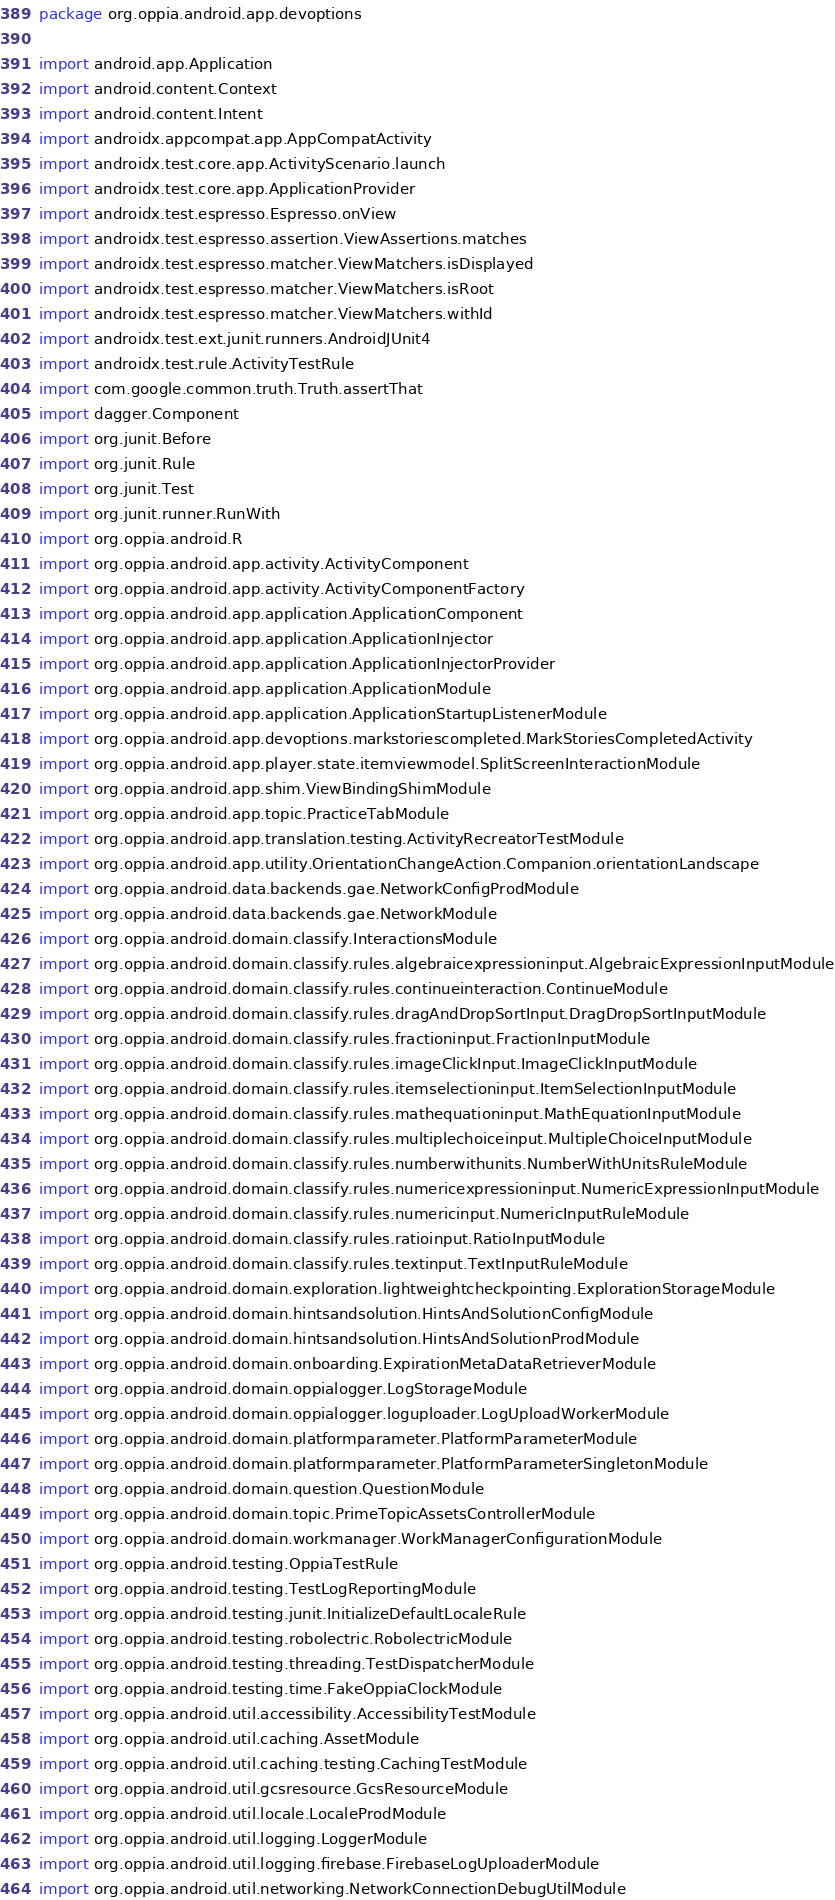<code> <loc_0><loc_0><loc_500><loc_500><_Kotlin_>package org.oppia.android.app.devoptions

import android.app.Application
import android.content.Context
import android.content.Intent
import androidx.appcompat.app.AppCompatActivity
import androidx.test.core.app.ActivityScenario.launch
import androidx.test.core.app.ApplicationProvider
import androidx.test.espresso.Espresso.onView
import androidx.test.espresso.assertion.ViewAssertions.matches
import androidx.test.espresso.matcher.ViewMatchers.isDisplayed
import androidx.test.espresso.matcher.ViewMatchers.isRoot
import androidx.test.espresso.matcher.ViewMatchers.withId
import androidx.test.ext.junit.runners.AndroidJUnit4
import androidx.test.rule.ActivityTestRule
import com.google.common.truth.Truth.assertThat
import dagger.Component
import org.junit.Before
import org.junit.Rule
import org.junit.Test
import org.junit.runner.RunWith
import org.oppia.android.R
import org.oppia.android.app.activity.ActivityComponent
import org.oppia.android.app.activity.ActivityComponentFactory
import org.oppia.android.app.application.ApplicationComponent
import org.oppia.android.app.application.ApplicationInjector
import org.oppia.android.app.application.ApplicationInjectorProvider
import org.oppia.android.app.application.ApplicationModule
import org.oppia.android.app.application.ApplicationStartupListenerModule
import org.oppia.android.app.devoptions.markstoriescompleted.MarkStoriesCompletedActivity
import org.oppia.android.app.player.state.itemviewmodel.SplitScreenInteractionModule
import org.oppia.android.app.shim.ViewBindingShimModule
import org.oppia.android.app.topic.PracticeTabModule
import org.oppia.android.app.translation.testing.ActivityRecreatorTestModule
import org.oppia.android.app.utility.OrientationChangeAction.Companion.orientationLandscape
import org.oppia.android.data.backends.gae.NetworkConfigProdModule
import org.oppia.android.data.backends.gae.NetworkModule
import org.oppia.android.domain.classify.InteractionsModule
import org.oppia.android.domain.classify.rules.algebraicexpressioninput.AlgebraicExpressionInputModule
import org.oppia.android.domain.classify.rules.continueinteraction.ContinueModule
import org.oppia.android.domain.classify.rules.dragAndDropSortInput.DragDropSortInputModule
import org.oppia.android.domain.classify.rules.fractioninput.FractionInputModule
import org.oppia.android.domain.classify.rules.imageClickInput.ImageClickInputModule
import org.oppia.android.domain.classify.rules.itemselectioninput.ItemSelectionInputModule
import org.oppia.android.domain.classify.rules.mathequationinput.MathEquationInputModule
import org.oppia.android.domain.classify.rules.multiplechoiceinput.MultipleChoiceInputModule
import org.oppia.android.domain.classify.rules.numberwithunits.NumberWithUnitsRuleModule
import org.oppia.android.domain.classify.rules.numericexpressioninput.NumericExpressionInputModule
import org.oppia.android.domain.classify.rules.numericinput.NumericInputRuleModule
import org.oppia.android.domain.classify.rules.ratioinput.RatioInputModule
import org.oppia.android.domain.classify.rules.textinput.TextInputRuleModule
import org.oppia.android.domain.exploration.lightweightcheckpointing.ExplorationStorageModule
import org.oppia.android.domain.hintsandsolution.HintsAndSolutionConfigModule
import org.oppia.android.domain.hintsandsolution.HintsAndSolutionProdModule
import org.oppia.android.domain.onboarding.ExpirationMetaDataRetrieverModule
import org.oppia.android.domain.oppialogger.LogStorageModule
import org.oppia.android.domain.oppialogger.loguploader.LogUploadWorkerModule
import org.oppia.android.domain.platformparameter.PlatformParameterModule
import org.oppia.android.domain.platformparameter.PlatformParameterSingletonModule
import org.oppia.android.domain.question.QuestionModule
import org.oppia.android.domain.topic.PrimeTopicAssetsControllerModule
import org.oppia.android.domain.workmanager.WorkManagerConfigurationModule
import org.oppia.android.testing.OppiaTestRule
import org.oppia.android.testing.TestLogReportingModule
import org.oppia.android.testing.junit.InitializeDefaultLocaleRule
import org.oppia.android.testing.robolectric.RobolectricModule
import org.oppia.android.testing.threading.TestDispatcherModule
import org.oppia.android.testing.time.FakeOppiaClockModule
import org.oppia.android.util.accessibility.AccessibilityTestModule
import org.oppia.android.util.caching.AssetModule
import org.oppia.android.util.caching.testing.CachingTestModule
import org.oppia.android.util.gcsresource.GcsResourceModule
import org.oppia.android.util.locale.LocaleProdModule
import org.oppia.android.util.logging.LoggerModule
import org.oppia.android.util.logging.firebase.FirebaseLogUploaderModule
import org.oppia.android.util.networking.NetworkConnectionDebugUtilModule</code> 